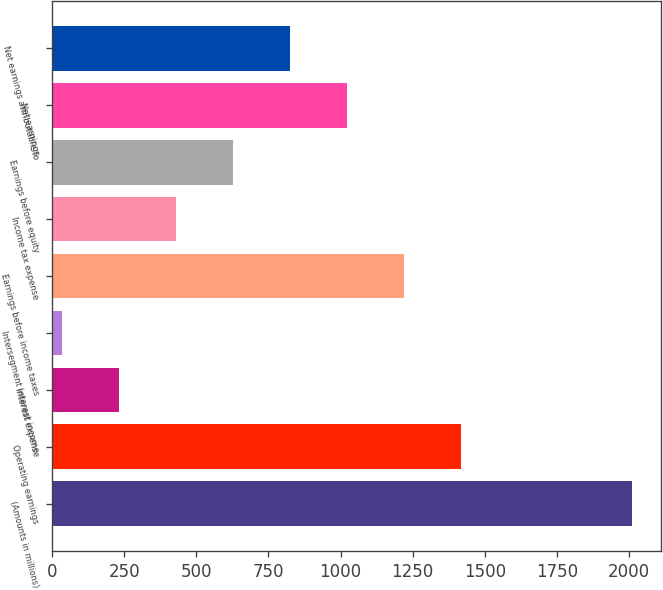Convert chart. <chart><loc_0><loc_0><loc_500><loc_500><bar_chart><fcel>(Amounts in millions)<fcel>Operating earnings<fcel>Interest expense<fcel>Intersegment interest income<fcel>Earnings before income taxes<fcel>Income tax expense<fcel>Earnings before equity<fcel>Net earnings<fcel>Net earnings attributable to<nl><fcel>2011<fcel>1418.44<fcel>233.32<fcel>35.8<fcel>1220.92<fcel>430.84<fcel>628.36<fcel>1023.4<fcel>825.88<nl></chart> 